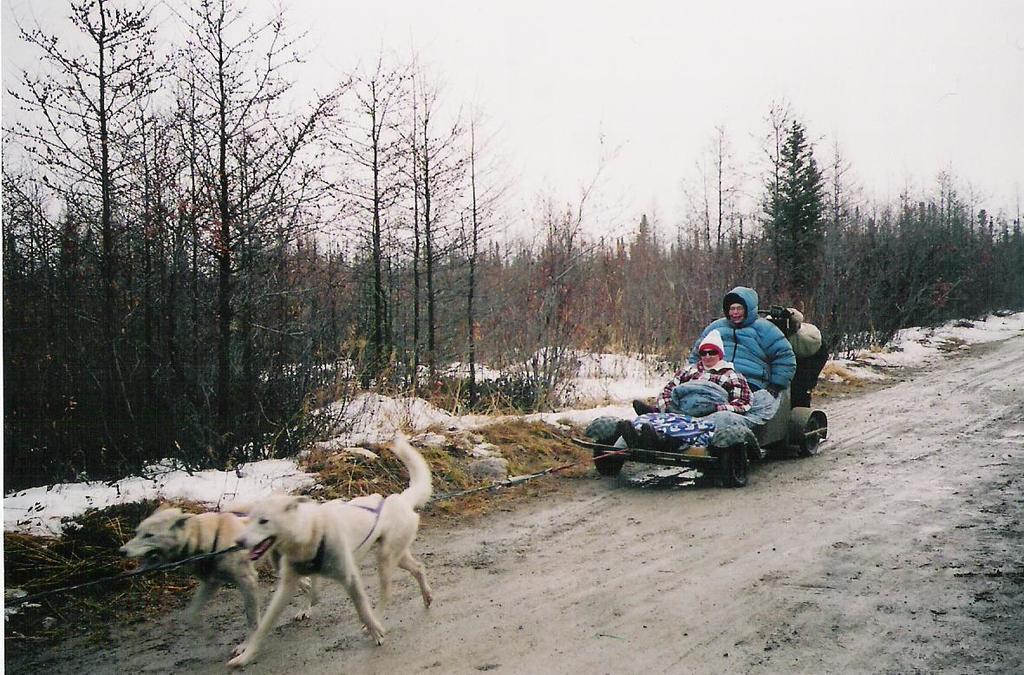In one or two sentences, can you explain what this image depicts? In this image in the center there is one vehicle, and in that vehicle there are two persons who are sitting and there are two dogs. At the bottom there is sand snow and some grass, in the background there are some trees. At the top of the image there is sky. 